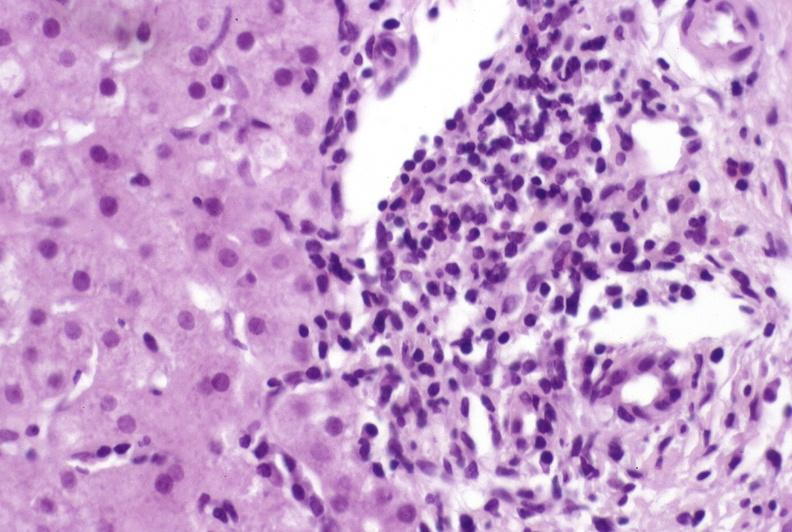s lymphangiomatosis generalized present?
Answer the question using a single word or phrase. No 